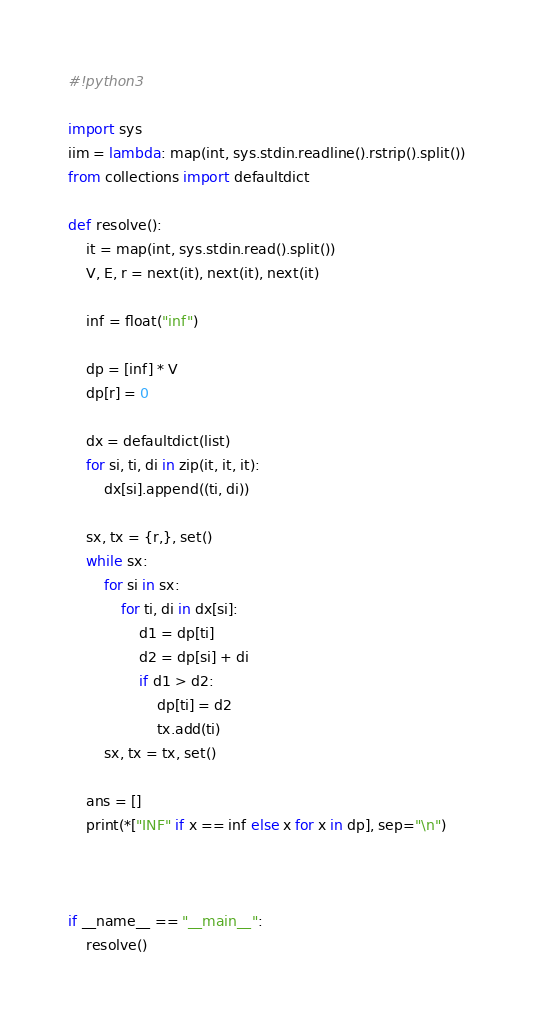<code> <loc_0><loc_0><loc_500><loc_500><_Python_>#!python3

import sys
iim = lambda: map(int, sys.stdin.readline().rstrip().split())
from collections import defaultdict

def resolve():
    it = map(int, sys.stdin.read().split())
    V, E, r = next(it), next(it), next(it)

    inf = float("inf")

    dp = [inf] * V
    dp[r] = 0

    dx = defaultdict(list)
    for si, ti, di in zip(it, it, it):
        dx[si].append((ti, di))

    sx, tx = {r,}, set()
    while sx:
        for si in sx:
            for ti, di in dx[si]:
                d1 = dp[ti]
                d2 = dp[si] + di
                if d1 > d2:
                    dp[ti] = d2
                    tx.add(ti)
        sx, tx = tx, set()

    ans = []
    print(*["INF" if x == inf else x for x in dp], sep="\n")



if __name__ == "__main__":
    resolve()

</code> 